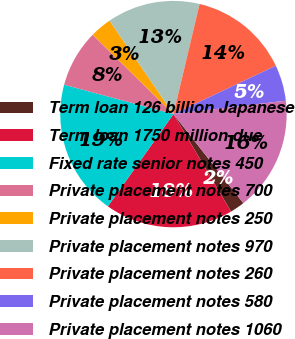Convert chart to OTSL. <chart><loc_0><loc_0><loc_500><loc_500><pie_chart><fcel>Term loan 126 billion Japanese<fcel>Term loan 1750 million due<fcel>Fixed rate senior notes 450<fcel>Private placement notes 700<fcel>Private placement notes 250<fcel>Private placement notes 970<fcel>Private placement notes 260<fcel>Private placement notes 580<fcel>Private placement notes 1060<nl><fcel>2.09%<fcel>18.33%<fcel>19.34%<fcel>8.18%<fcel>3.1%<fcel>13.25%<fcel>14.27%<fcel>5.13%<fcel>16.3%<nl></chart> 